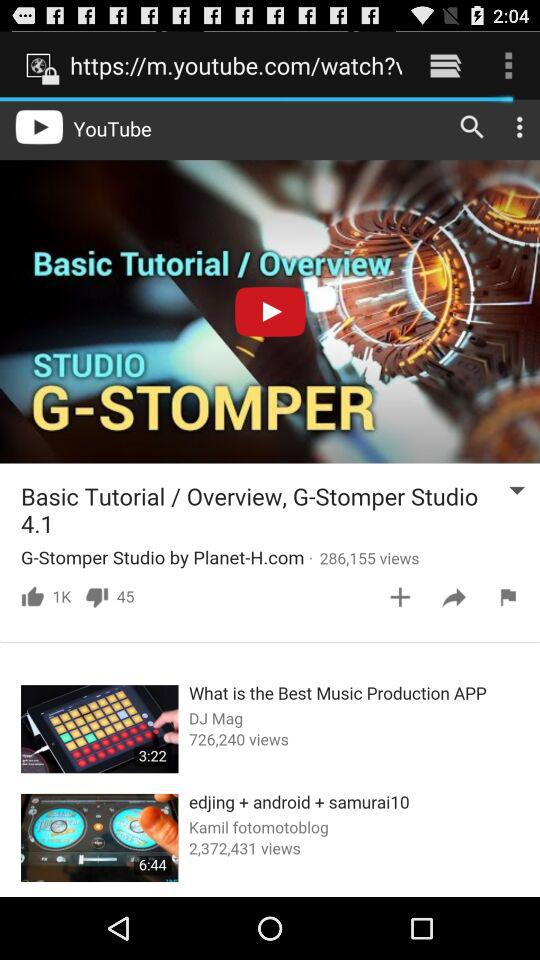How many people watched the video "edjing + android + samurai10"? The people who watched the video are 2,372,431. 